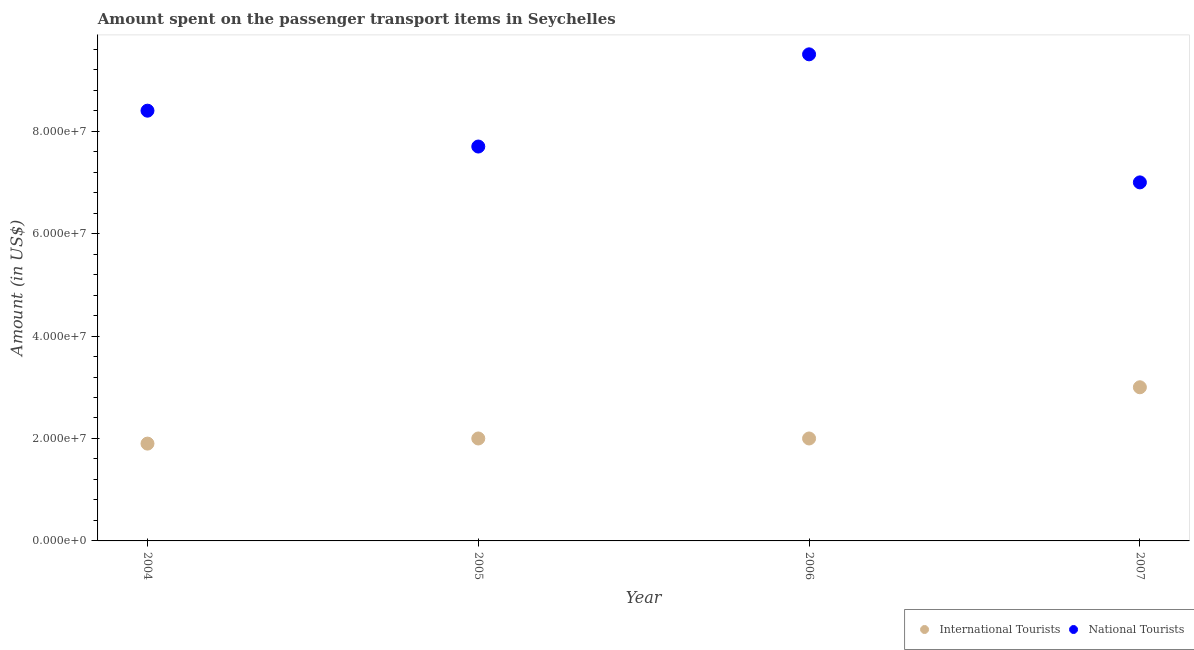How many different coloured dotlines are there?
Offer a terse response. 2. What is the amount spent on transport items of international tourists in 2006?
Provide a short and direct response. 2.00e+07. Across all years, what is the maximum amount spent on transport items of national tourists?
Provide a succinct answer. 9.50e+07. Across all years, what is the minimum amount spent on transport items of national tourists?
Keep it short and to the point. 7.00e+07. In which year was the amount spent on transport items of international tourists minimum?
Your response must be concise. 2004. What is the total amount spent on transport items of international tourists in the graph?
Provide a succinct answer. 8.90e+07. What is the difference between the amount spent on transport items of international tourists in 2004 and that in 2005?
Ensure brevity in your answer.  -1.00e+06. What is the difference between the amount spent on transport items of international tourists in 2007 and the amount spent on transport items of national tourists in 2006?
Ensure brevity in your answer.  -6.50e+07. What is the average amount spent on transport items of national tourists per year?
Offer a very short reply. 8.15e+07. In the year 2007, what is the difference between the amount spent on transport items of national tourists and amount spent on transport items of international tourists?
Your answer should be compact. 4.00e+07. In how many years, is the amount spent on transport items of international tourists greater than 52000000 US$?
Make the answer very short. 0. What is the ratio of the amount spent on transport items of international tourists in 2004 to that in 2006?
Offer a terse response. 0.95. Is the amount spent on transport items of national tourists in 2004 less than that in 2006?
Offer a terse response. Yes. What is the difference between the highest and the lowest amount spent on transport items of international tourists?
Your answer should be very brief. 1.10e+07. Is the sum of the amount spent on transport items of national tourists in 2006 and 2007 greater than the maximum amount spent on transport items of international tourists across all years?
Keep it short and to the point. Yes. Does the amount spent on transport items of international tourists monotonically increase over the years?
Provide a short and direct response. No. Is the amount spent on transport items of national tourists strictly less than the amount spent on transport items of international tourists over the years?
Your answer should be compact. No. How many years are there in the graph?
Keep it short and to the point. 4. Where does the legend appear in the graph?
Offer a very short reply. Bottom right. How many legend labels are there?
Offer a very short reply. 2. How are the legend labels stacked?
Your answer should be very brief. Horizontal. What is the title of the graph?
Keep it short and to the point. Amount spent on the passenger transport items in Seychelles. Does "Fixed telephone" appear as one of the legend labels in the graph?
Ensure brevity in your answer.  No. What is the Amount (in US$) in International Tourists in 2004?
Your answer should be compact. 1.90e+07. What is the Amount (in US$) of National Tourists in 2004?
Your answer should be compact. 8.40e+07. What is the Amount (in US$) in International Tourists in 2005?
Ensure brevity in your answer.  2.00e+07. What is the Amount (in US$) in National Tourists in 2005?
Keep it short and to the point. 7.70e+07. What is the Amount (in US$) of National Tourists in 2006?
Offer a very short reply. 9.50e+07. What is the Amount (in US$) of International Tourists in 2007?
Your answer should be very brief. 3.00e+07. What is the Amount (in US$) of National Tourists in 2007?
Give a very brief answer. 7.00e+07. Across all years, what is the maximum Amount (in US$) of International Tourists?
Your answer should be compact. 3.00e+07. Across all years, what is the maximum Amount (in US$) of National Tourists?
Keep it short and to the point. 9.50e+07. Across all years, what is the minimum Amount (in US$) in International Tourists?
Make the answer very short. 1.90e+07. Across all years, what is the minimum Amount (in US$) in National Tourists?
Your answer should be compact. 7.00e+07. What is the total Amount (in US$) in International Tourists in the graph?
Give a very brief answer. 8.90e+07. What is the total Amount (in US$) of National Tourists in the graph?
Offer a very short reply. 3.26e+08. What is the difference between the Amount (in US$) of International Tourists in 2004 and that in 2005?
Ensure brevity in your answer.  -1.00e+06. What is the difference between the Amount (in US$) of National Tourists in 2004 and that in 2006?
Provide a succinct answer. -1.10e+07. What is the difference between the Amount (in US$) of International Tourists in 2004 and that in 2007?
Provide a short and direct response. -1.10e+07. What is the difference between the Amount (in US$) of National Tourists in 2004 and that in 2007?
Your answer should be compact. 1.40e+07. What is the difference between the Amount (in US$) in National Tourists in 2005 and that in 2006?
Give a very brief answer. -1.80e+07. What is the difference between the Amount (in US$) in International Tourists in 2005 and that in 2007?
Make the answer very short. -1.00e+07. What is the difference between the Amount (in US$) of National Tourists in 2005 and that in 2007?
Keep it short and to the point. 7.00e+06. What is the difference between the Amount (in US$) of International Tourists in 2006 and that in 2007?
Offer a terse response. -1.00e+07. What is the difference between the Amount (in US$) in National Tourists in 2006 and that in 2007?
Your answer should be very brief. 2.50e+07. What is the difference between the Amount (in US$) of International Tourists in 2004 and the Amount (in US$) of National Tourists in 2005?
Offer a very short reply. -5.80e+07. What is the difference between the Amount (in US$) of International Tourists in 2004 and the Amount (in US$) of National Tourists in 2006?
Make the answer very short. -7.60e+07. What is the difference between the Amount (in US$) in International Tourists in 2004 and the Amount (in US$) in National Tourists in 2007?
Your answer should be compact. -5.10e+07. What is the difference between the Amount (in US$) of International Tourists in 2005 and the Amount (in US$) of National Tourists in 2006?
Offer a terse response. -7.50e+07. What is the difference between the Amount (in US$) of International Tourists in 2005 and the Amount (in US$) of National Tourists in 2007?
Your answer should be compact. -5.00e+07. What is the difference between the Amount (in US$) of International Tourists in 2006 and the Amount (in US$) of National Tourists in 2007?
Offer a very short reply. -5.00e+07. What is the average Amount (in US$) of International Tourists per year?
Provide a succinct answer. 2.22e+07. What is the average Amount (in US$) in National Tourists per year?
Provide a succinct answer. 8.15e+07. In the year 2004, what is the difference between the Amount (in US$) in International Tourists and Amount (in US$) in National Tourists?
Your response must be concise. -6.50e+07. In the year 2005, what is the difference between the Amount (in US$) of International Tourists and Amount (in US$) of National Tourists?
Provide a succinct answer. -5.70e+07. In the year 2006, what is the difference between the Amount (in US$) of International Tourists and Amount (in US$) of National Tourists?
Give a very brief answer. -7.50e+07. In the year 2007, what is the difference between the Amount (in US$) of International Tourists and Amount (in US$) of National Tourists?
Provide a succinct answer. -4.00e+07. What is the ratio of the Amount (in US$) of National Tourists in 2004 to that in 2005?
Make the answer very short. 1.09. What is the ratio of the Amount (in US$) of National Tourists in 2004 to that in 2006?
Offer a terse response. 0.88. What is the ratio of the Amount (in US$) in International Tourists in 2004 to that in 2007?
Keep it short and to the point. 0.63. What is the ratio of the Amount (in US$) in International Tourists in 2005 to that in 2006?
Your answer should be compact. 1. What is the ratio of the Amount (in US$) in National Tourists in 2005 to that in 2006?
Your answer should be compact. 0.81. What is the ratio of the Amount (in US$) of International Tourists in 2006 to that in 2007?
Keep it short and to the point. 0.67. What is the ratio of the Amount (in US$) in National Tourists in 2006 to that in 2007?
Make the answer very short. 1.36. What is the difference between the highest and the second highest Amount (in US$) of National Tourists?
Your response must be concise. 1.10e+07. What is the difference between the highest and the lowest Amount (in US$) in International Tourists?
Keep it short and to the point. 1.10e+07. What is the difference between the highest and the lowest Amount (in US$) of National Tourists?
Ensure brevity in your answer.  2.50e+07. 